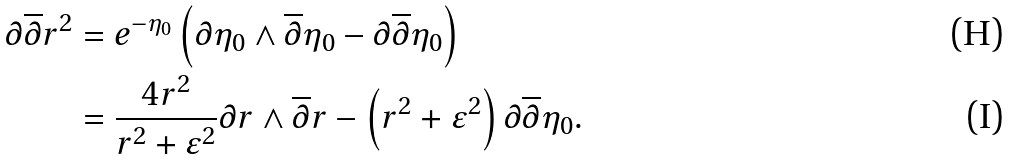Convert formula to latex. <formula><loc_0><loc_0><loc_500><loc_500>\partial \overline { \partial } { r ^ { 2 } } & = e ^ { - \eta _ { 0 } } \left ( \partial { \eta _ { 0 } } \wedge \overline { \partial } { \eta _ { 0 } } - \partial \overline { \partial } { \eta _ { 0 } } \right ) \\ & = \frac { 4 r ^ { 2 } } { r ^ { 2 } + \varepsilon ^ { 2 } } \partial { r } \wedge \overline { \partial } { r } - \left ( r ^ { 2 } + \varepsilon ^ { 2 } \right ) \partial \overline { \partial } { \eta _ { 0 } } .</formula> 